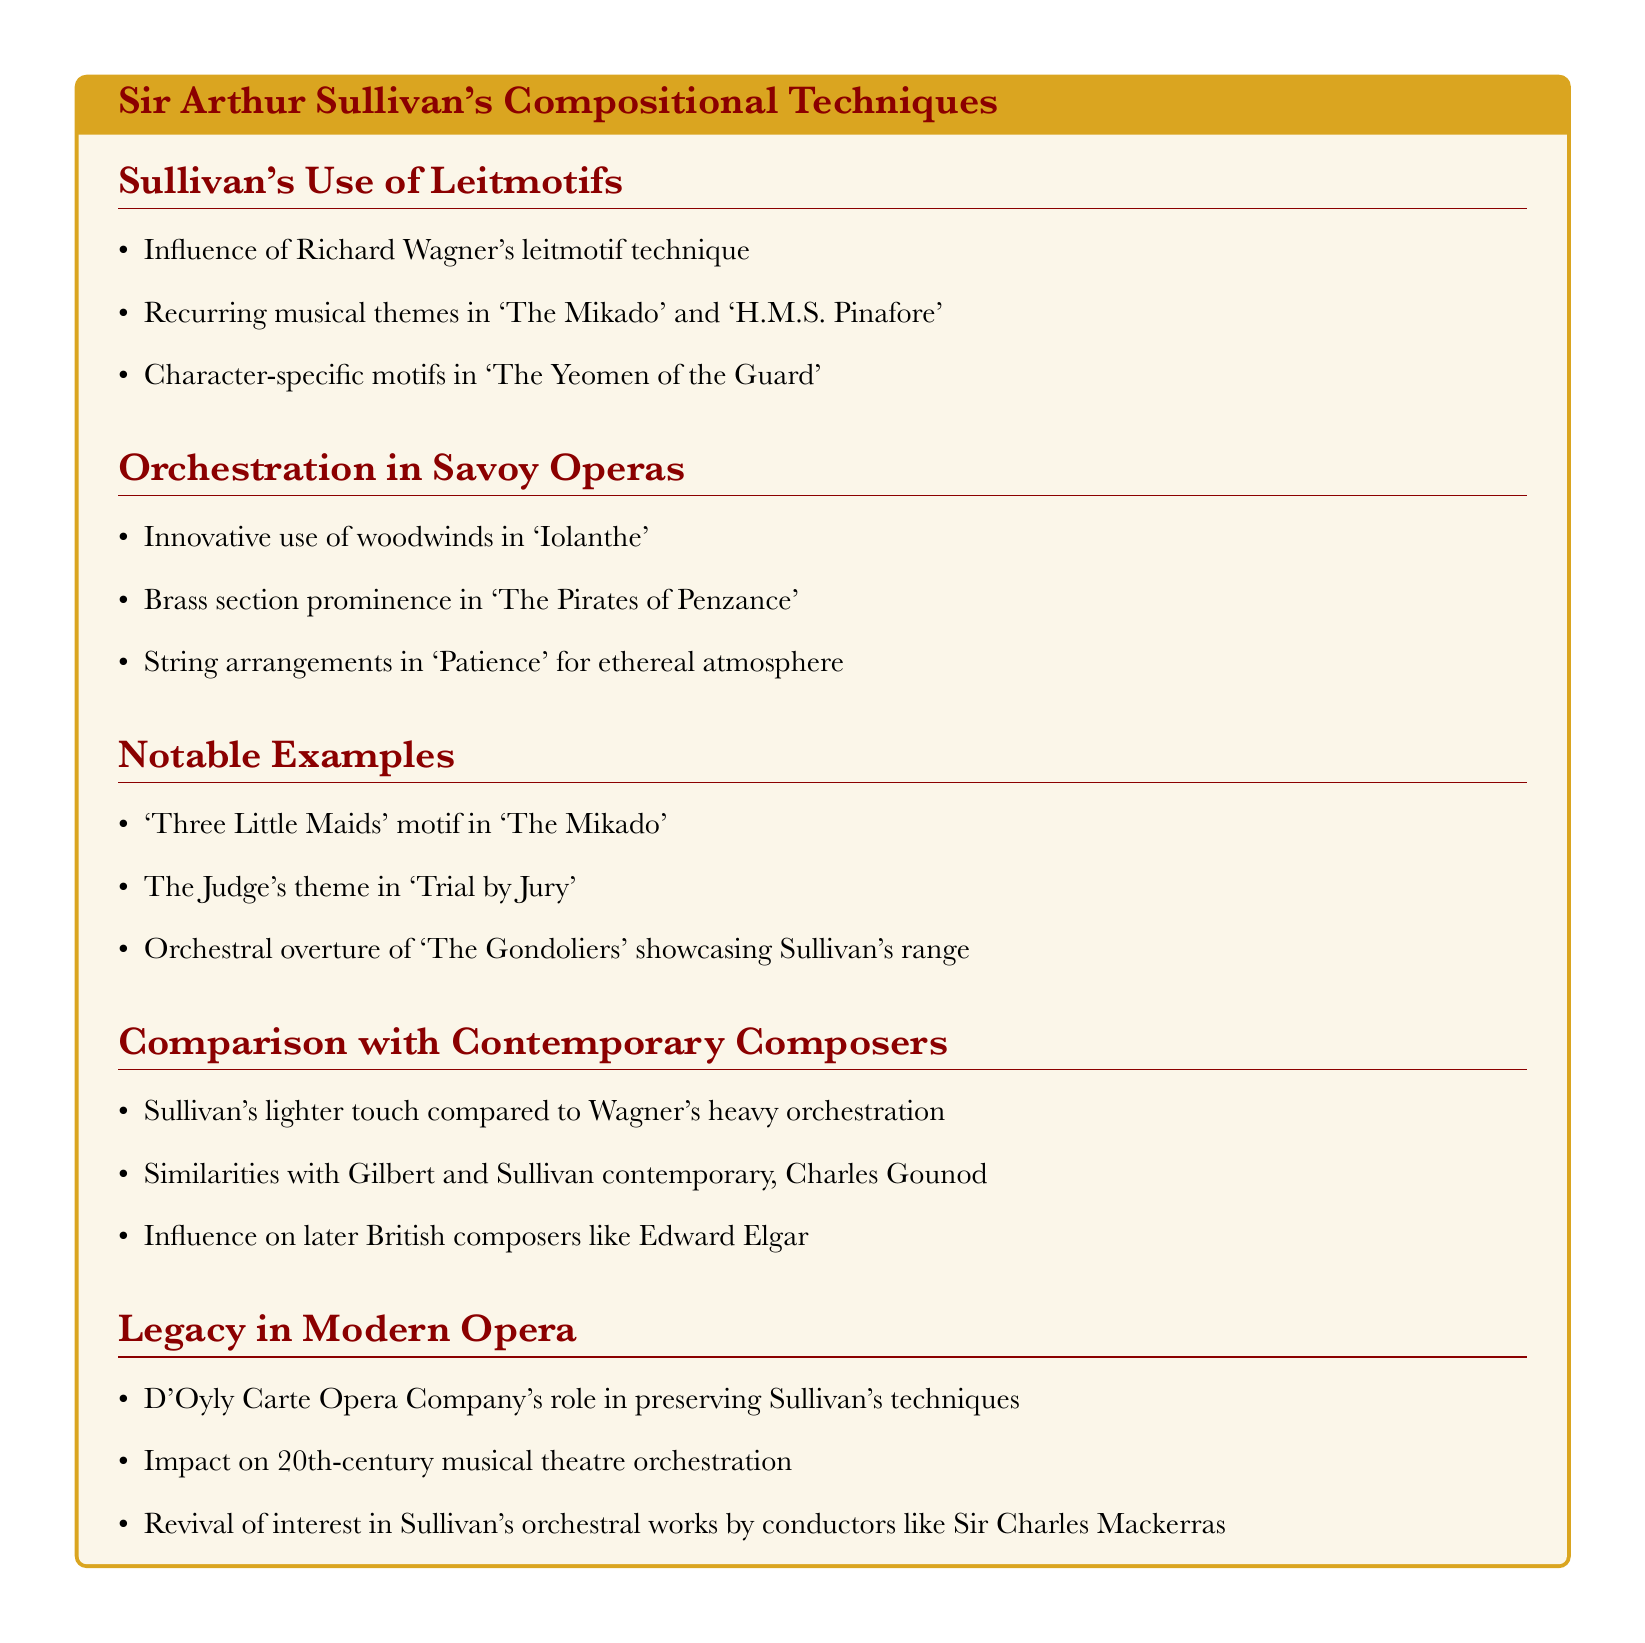What technique influenced Sullivan's use of leitmotifs? The document states that Sullivan's use of leitmotifs was influenced by Richard Wagner's technique.
Answer: Richard Wagner's leitmotif technique Name a recurring musical theme in Sullivan's operas. The document mentions recurring musical themes specifically in 'The Mikado' and 'H.M.S. Pinafore.'
Answer: 'The Mikado' and 'H.M.S. Pinafore' Which brass section is prominent in 'The Pirates of Penzance'? The document notes that the brass section is prominent in the operatic work 'The Pirates of Penzance.'
Answer: Brass section What motif is highlighted in 'The Mikado'? The document provides a specific example, noting the 'Three Little Maids' motif in 'The Mikado.'
Answer: 'Three Little Maids' Which composer is noted for having similarities with Sullivan? The document mentions Charles Gounod as a contemporary with similarities to Sullivan.
Answer: Charles Gounod What role did the D'Oyly Carte Opera Company play in relation to Sullivan? According to the document, the D'Oyly Carte Opera Company played a role in preserving Sullivan's techniques.
Answer: Preserving Sullivan's techniques Which conductor revived interest in Sullivan's orchestral works? The document notes that Sir Charles Mackerras revived interest in Sullivan's orchestral works.
Answer: Sir Charles Mackerras What is a notable feature of the orchestration in 'Iolanthe'? The document states that there is an innovative use of woodwinds in 'Iolanthe.'
Answer: Innovative use of woodwinds 